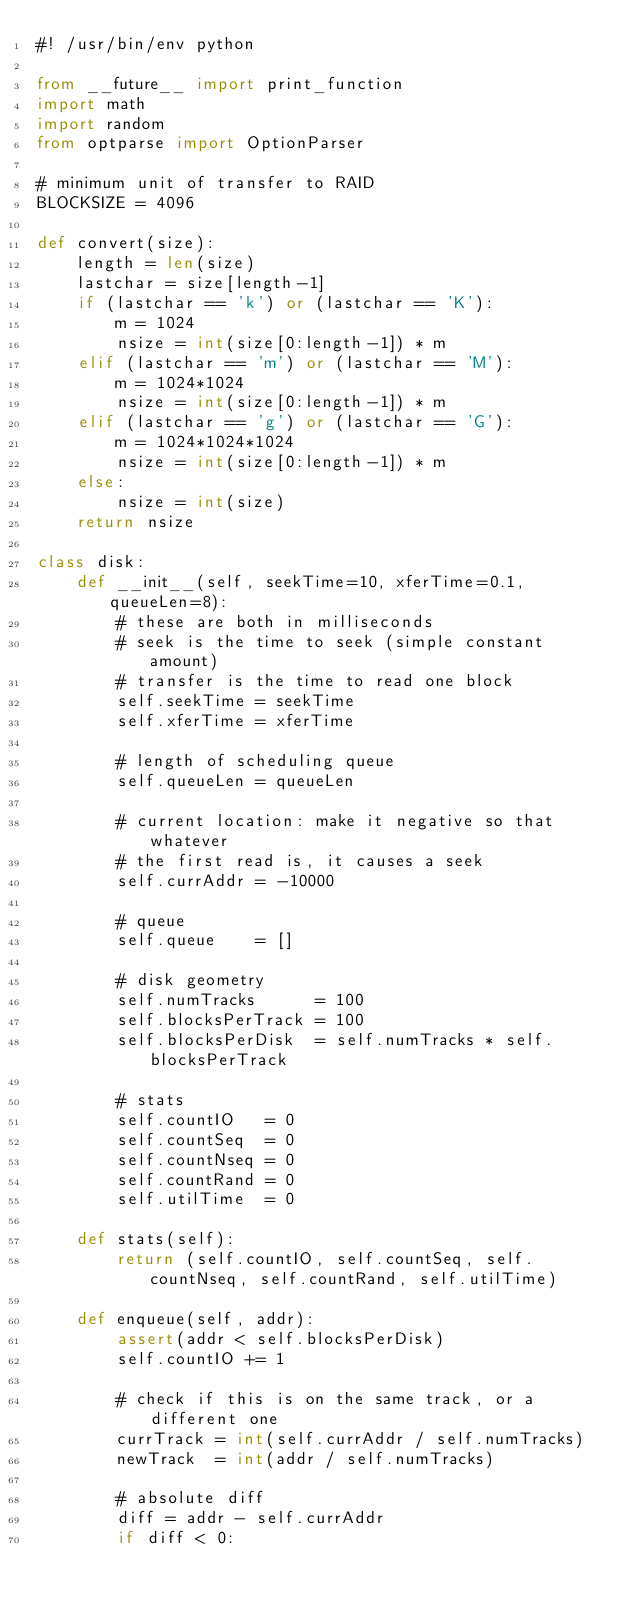Convert code to text. <code><loc_0><loc_0><loc_500><loc_500><_Python_>#! /usr/bin/env python

from __future__ import print_function
import math
import random
from optparse import OptionParser

# minimum unit of transfer to RAID
BLOCKSIZE = 4096

def convert(size):
    length = len(size)
    lastchar = size[length-1]
    if (lastchar == 'k') or (lastchar == 'K'):
        m = 1024
        nsize = int(size[0:length-1]) * m
    elif (lastchar == 'm') or (lastchar == 'M'):
        m = 1024*1024
        nsize = int(size[0:length-1]) * m
    elif (lastchar == 'g') or (lastchar == 'G'):
        m = 1024*1024*1024
        nsize = int(size[0:length-1]) * m
    else:
        nsize = int(size)
    return nsize

class disk:
    def __init__(self, seekTime=10, xferTime=0.1, queueLen=8):
        # these are both in milliseconds
        # seek is the time to seek (simple constant amount)
        # transfer is the time to read one block
        self.seekTime = seekTime
        self.xferTime = xferTime

        # length of scheduling queue
        self.queueLen = queueLen

        # current location: make it negative so that whatever
        # the first read is, it causes a seek 
        self.currAddr = -10000

        # queue
        self.queue    = []

        # disk geometry
        self.numTracks      = 100
        self.blocksPerTrack = 100
        self.blocksPerDisk  = self.numTracks * self.blocksPerTrack

        # stats
        self.countIO   = 0
        self.countSeq  = 0
        self.countNseq = 0
        self.countRand = 0
        self.utilTime  = 0

    def stats(self):
        return (self.countIO, self.countSeq, self.countNseq, self.countRand, self.utilTime)

    def enqueue(self, addr):
        assert(addr < self.blocksPerDisk)
        self.countIO += 1

        # check if this is on the same track, or a different one
        currTrack = int(self.currAddr / self.numTracks)
        newTrack  = int(addr / self.numTracks)

        # absolute diff
        diff = addr - self.currAddr
        if diff < 0:</code> 